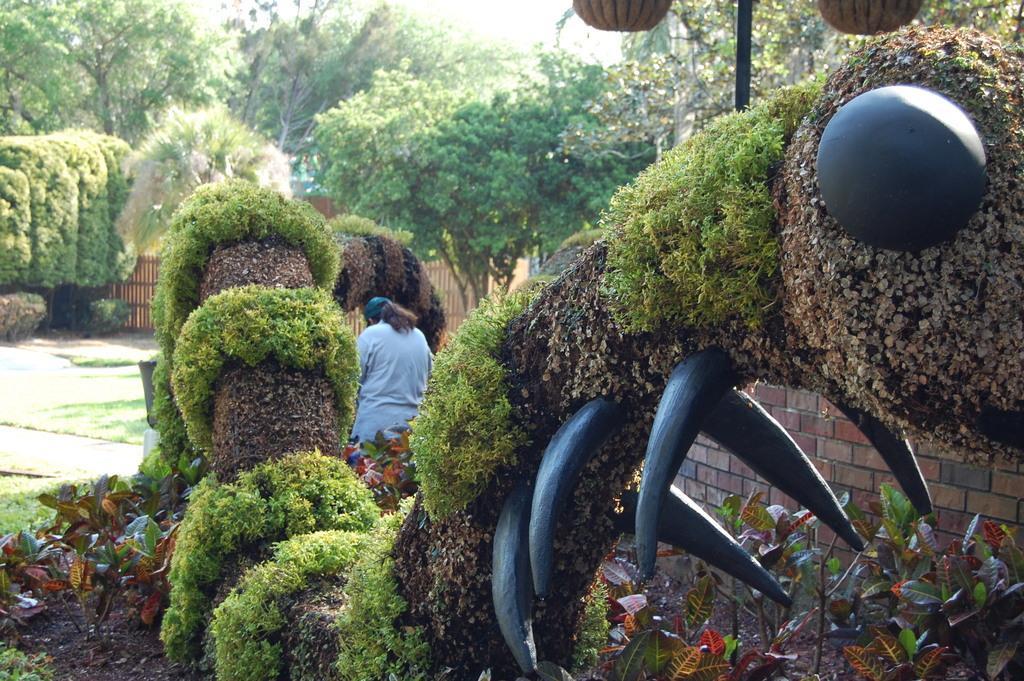Please provide a concise description of this image. In the image we can see a person wearing clothes and a cap, this is a grass, plant, trees, fence, pole and an object. 